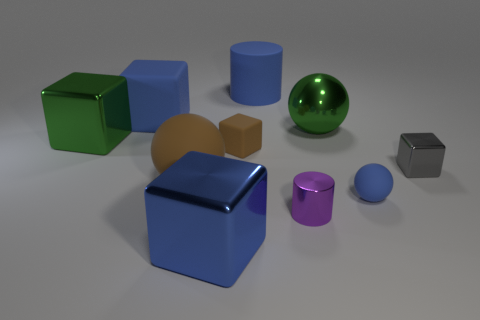What can you infer about the scene's lighting based on the shadows? The scene appears to be lit by a single light source situated above and to the right of the objects, as indicated by the shadows cast to the left and slightly downwards. 